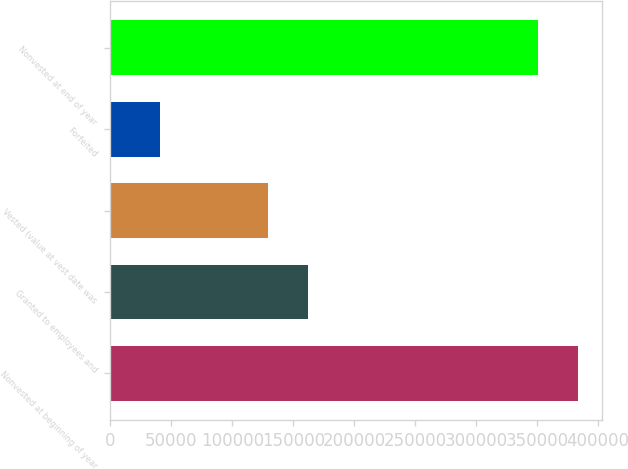Convert chart to OTSL. <chart><loc_0><loc_0><loc_500><loc_500><bar_chart><fcel>Nonvested at beginning of year<fcel>Granted to employees and<fcel>Vested (value at vest date was<fcel>Forfeited<fcel>Nonvested at end of year<nl><fcel>383784<fcel>161872<fcel>129105<fcel>40529<fcel>351017<nl></chart> 